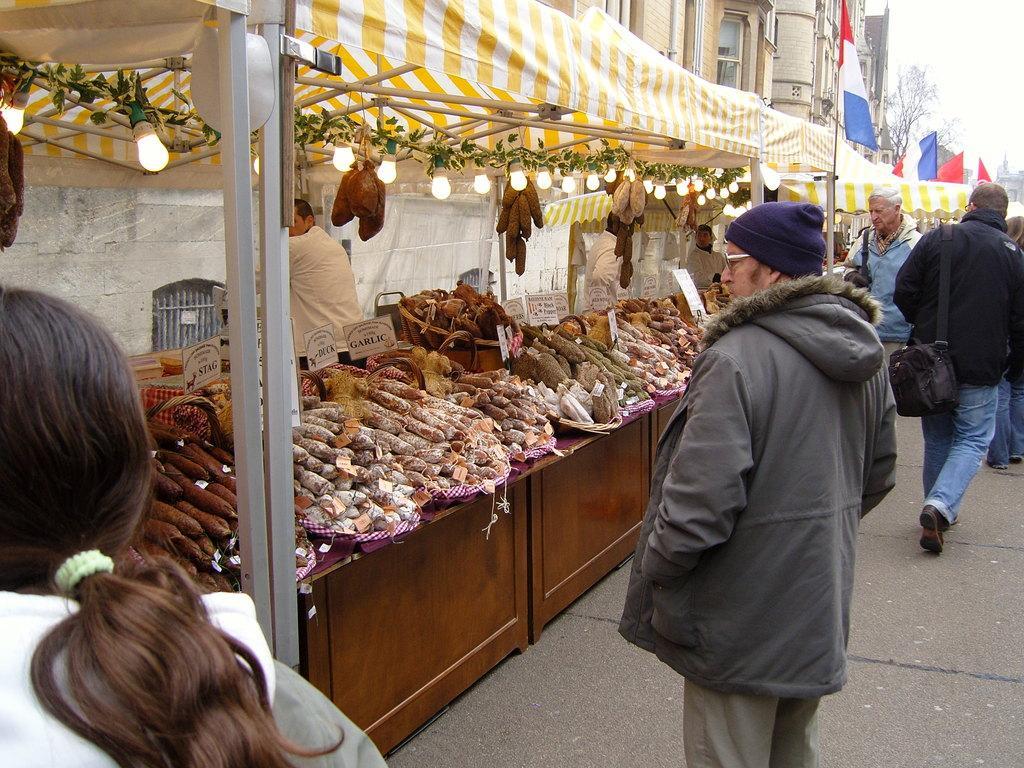Describe this image in one or two sentences. This picture is clicked outside. On the right we can see the group of persons. On the left there is a person standing under the tent and we can see the bulbs are hanging on the metal rods and there are some items placed on the top of the wooden objects. In the background there is a sky, buildings and flags. 